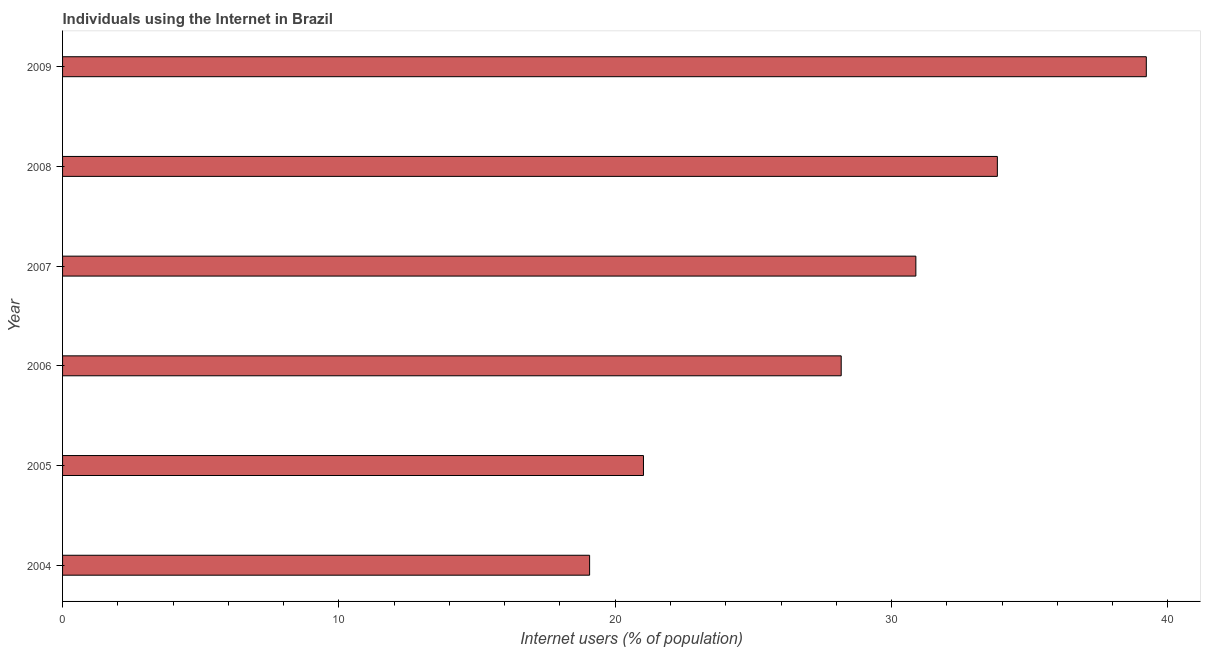What is the title of the graph?
Make the answer very short. Individuals using the Internet in Brazil. What is the label or title of the X-axis?
Your answer should be compact. Internet users (% of population). What is the label or title of the Y-axis?
Your answer should be very brief. Year. What is the number of internet users in 2005?
Offer a terse response. 21.02. Across all years, what is the maximum number of internet users?
Give a very brief answer. 39.22. Across all years, what is the minimum number of internet users?
Your answer should be compact. 19.07. In which year was the number of internet users minimum?
Provide a succinct answer. 2004. What is the sum of the number of internet users?
Give a very brief answer. 172.2. What is the difference between the number of internet users in 2004 and 2008?
Provide a short and direct response. -14.76. What is the average number of internet users per year?
Offer a terse response. 28.7. What is the median number of internet users?
Your answer should be compact. 29.53. In how many years, is the number of internet users greater than 10 %?
Your answer should be very brief. 6. Do a majority of the years between 2009 and 2006 (inclusive) have number of internet users greater than 14 %?
Keep it short and to the point. Yes. What is the ratio of the number of internet users in 2004 to that in 2009?
Provide a succinct answer. 0.49. What is the difference between the highest and the second highest number of internet users?
Make the answer very short. 5.39. Is the sum of the number of internet users in 2005 and 2006 greater than the maximum number of internet users across all years?
Your answer should be compact. Yes. What is the difference between the highest and the lowest number of internet users?
Keep it short and to the point. 20.15. In how many years, is the number of internet users greater than the average number of internet users taken over all years?
Give a very brief answer. 3. How many years are there in the graph?
Your response must be concise. 6. What is the difference between two consecutive major ticks on the X-axis?
Offer a terse response. 10. What is the Internet users (% of population) of 2004?
Offer a terse response. 19.07. What is the Internet users (% of population) in 2005?
Your response must be concise. 21.02. What is the Internet users (% of population) in 2006?
Offer a very short reply. 28.18. What is the Internet users (% of population) in 2007?
Give a very brief answer. 30.88. What is the Internet users (% of population) in 2008?
Ensure brevity in your answer.  33.83. What is the Internet users (% of population) in 2009?
Provide a short and direct response. 39.22. What is the difference between the Internet users (% of population) in 2004 and 2005?
Give a very brief answer. -1.95. What is the difference between the Internet users (% of population) in 2004 and 2006?
Keep it short and to the point. -9.1. What is the difference between the Internet users (% of population) in 2004 and 2007?
Keep it short and to the point. -11.81. What is the difference between the Internet users (% of population) in 2004 and 2008?
Offer a terse response. -14.76. What is the difference between the Internet users (% of population) in 2004 and 2009?
Your answer should be compact. -20.15. What is the difference between the Internet users (% of population) in 2005 and 2006?
Keep it short and to the point. -7.16. What is the difference between the Internet users (% of population) in 2005 and 2007?
Your answer should be compact. -9.86. What is the difference between the Internet users (% of population) in 2005 and 2008?
Keep it short and to the point. -12.81. What is the difference between the Internet users (% of population) in 2005 and 2009?
Offer a terse response. -18.2. What is the difference between the Internet users (% of population) in 2006 and 2007?
Keep it short and to the point. -2.7. What is the difference between the Internet users (% of population) in 2006 and 2008?
Provide a succinct answer. -5.65. What is the difference between the Internet users (% of population) in 2006 and 2009?
Keep it short and to the point. -11.04. What is the difference between the Internet users (% of population) in 2007 and 2008?
Ensure brevity in your answer.  -2.95. What is the difference between the Internet users (% of population) in 2007 and 2009?
Your response must be concise. -8.34. What is the difference between the Internet users (% of population) in 2008 and 2009?
Your answer should be very brief. -5.39. What is the ratio of the Internet users (% of population) in 2004 to that in 2005?
Your response must be concise. 0.91. What is the ratio of the Internet users (% of population) in 2004 to that in 2006?
Your answer should be very brief. 0.68. What is the ratio of the Internet users (% of population) in 2004 to that in 2007?
Make the answer very short. 0.62. What is the ratio of the Internet users (% of population) in 2004 to that in 2008?
Offer a terse response. 0.56. What is the ratio of the Internet users (% of population) in 2004 to that in 2009?
Your answer should be compact. 0.49. What is the ratio of the Internet users (% of population) in 2005 to that in 2006?
Your response must be concise. 0.75. What is the ratio of the Internet users (% of population) in 2005 to that in 2007?
Keep it short and to the point. 0.68. What is the ratio of the Internet users (% of population) in 2005 to that in 2008?
Provide a short and direct response. 0.62. What is the ratio of the Internet users (% of population) in 2005 to that in 2009?
Keep it short and to the point. 0.54. What is the ratio of the Internet users (% of population) in 2006 to that in 2008?
Provide a short and direct response. 0.83. What is the ratio of the Internet users (% of population) in 2006 to that in 2009?
Your answer should be compact. 0.72. What is the ratio of the Internet users (% of population) in 2007 to that in 2009?
Your answer should be compact. 0.79. What is the ratio of the Internet users (% of population) in 2008 to that in 2009?
Provide a succinct answer. 0.86. 